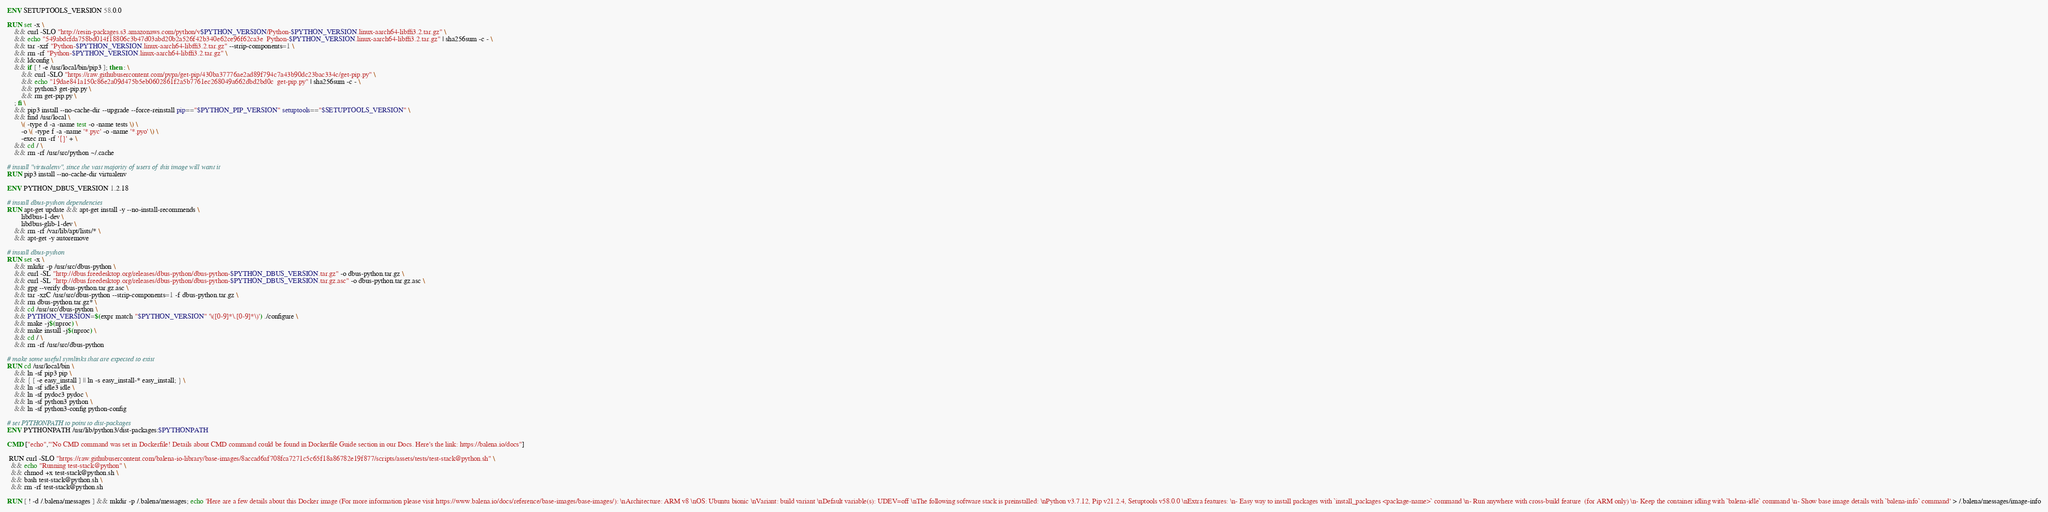Convert code to text. <code><loc_0><loc_0><loc_500><loc_500><_Dockerfile_>
ENV SETUPTOOLS_VERSION 58.0.0

RUN set -x \
	&& curl -SLO "http://resin-packages.s3.amazonaws.com/python/v$PYTHON_VERSION/Python-$PYTHON_VERSION.linux-aarch64-libffi3.2.tar.gz" \
	&& echo "549abdcfda758bd014f18806c3b47d03abd20b2a526f42b340e62ce96f62ca3e  Python-$PYTHON_VERSION.linux-aarch64-libffi3.2.tar.gz" | sha256sum -c - \
	&& tar -xzf "Python-$PYTHON_VERSION.linux-aarch64-libffi3.2.tar.gz" --strip-components=1 \
	&& rm -rf "Python-$PYTHON_VERSION.linux-aarch64-libffi3.2.tar.gz" \
	&& ldconfig \
	&& if [ ! -e /usr/local/bin/pip3 ]; then : \
		&& curl -SLO "https://raw.githubusercontent.com/pypa/get-pip/430ba37776ae2ad89f794c7a43b90dc23bac334c/get-pip.py" \
		&& echo "19dae841a150c86e2a09d475b5eb0602861f2a5b7761ec268049a662dbd2bd0c  get-pip.py" | sha256sum -c - \
		&& python3 get-pip.py \
		&& rm get-pip.py \
	; fi \
	&& pip3 install --no-cache-dir --upgrade --force-reinstall pip=="$PYTHON_PIP_VERSION" setuptools=="$SETUPTOOLS_VERSION" \
	&& find /usr/local \
		\( -type d -a -name test -o -name tests \) \
		-o \( -type f -a -name '*.pyc' -o -name '*.pyo' \) \
		-exec rm -rf '{}' + \
	&& cd / \
	&& rm -rf /usr/src/python ~/.cache

# install "virtualenv", since the vast majority of users of this image will want it
RUN pip3 install --no-cache-dir virtualenv

ENV PYTHON_DBUS_VERSION 1.2.18

# install dbus-python dependencies 
RUN apt-get update && apt-get install -y --no-install-recommends \
		libdbus-1-dev \
		libdbus-glib-1-dev \
	&& rm -rf /var/lib/apt/lists/* \
	&& apt-get -y autoremove

# install dbus-python
RUN set -x \
	&& mkdir -p /usr/src/dbus-python \
	&& curl -SL "http://dbus.freedesktop.org/releases/dbus-python/dbus-python-$PYTHON_DBUS_VERSION.tar.gz" -o dbus-python.tar.gz \
	&& curl -SL "http://dbus.freedesktop.org/releases/dbus-python/dbus-python-$PYTHON_DBUS_VERSION.tar.gz.asc" -o dbus-python.tar.gz.asc \
	&& gpg --verify dbus-python.tar.gz.asc \
	&& tar -xzC /usr/src/dbus-python --strip-components=1 -f dbus-python.tar.gz \
	&& rm dbus-python.tar.gz* \
	&& cd /usr/src/dbus-python \
	&& PYTHON_VERSION=$(expr match "$PYTHON_VERSION" '\([0-9]*\.[0-9]*\)') ./configure \
	&& make -j$(nproc) \
	&& make install -j$(nproc) \
	&& cd / \
	&& rm -rf /usr/src/dbus-python

# make some useful symlinks that are expected to exist
RUN cd /usr/local/bin \
	&& ln -sf pip3 pip \
	&& { [ -e easy_install ] || ln -s easy_install-* easy_install; } \
	&& ln -sf idle3 idle \
	&& ln -sf pydoc3 pydoc \
	&& ln -sf python3 python \
	&& ln -sf python3-config python-config

# set PYTHONPATH to point to dist-packages
ENV PYTHONPATH /usr/lib/python3/dist-packages:$PYTHONPATH

CMD ["echo","'No CMD command was set in Dockerfile! Details about CMD command could be found in Dockerfile Guide section in our Docs. Here's the link: https://balena.io/docs"]

 RUN curl -SLO "https://raw.githubusercontent.com/balena-io-library/base-images/8accad6af708fca7271c5c65f18a86782e19f877/scripts/assets/tests/test-stack@python.sh" \
  && echo "Running test-stack@python" \
  && chmod +x test-stack@python.sh \
  && bash test-stack@python.sh \
  && rm -rf test-stack@python.sh 

RUN [ ! -d /.balena/messages ] && mkdir -p /.balena/messages; echo 'Here are a few details about this Docker image (For more information please visit https://www.balena.io/docs/reference/base-images/base-images/): \nArchitecture: ARM v8 \nOS: Ubuntu bionic \nVariant: build variant \nDefault variable(s): UDEV=off \nThe following software stack is preinstalled: \nPython v3.7.12, Pip v21.2.4, Setuptools v58.0.0 \nExtra features: \n- Easy way to install packages with `install_packages <package-name>` command \n- Run anywhere with cross-build feature  (for ARM only) \n- Keep the container idling with `balena-idle` command \n- Show base image details with `balena-info` command' > /.balena/messages/image-info
</code> 